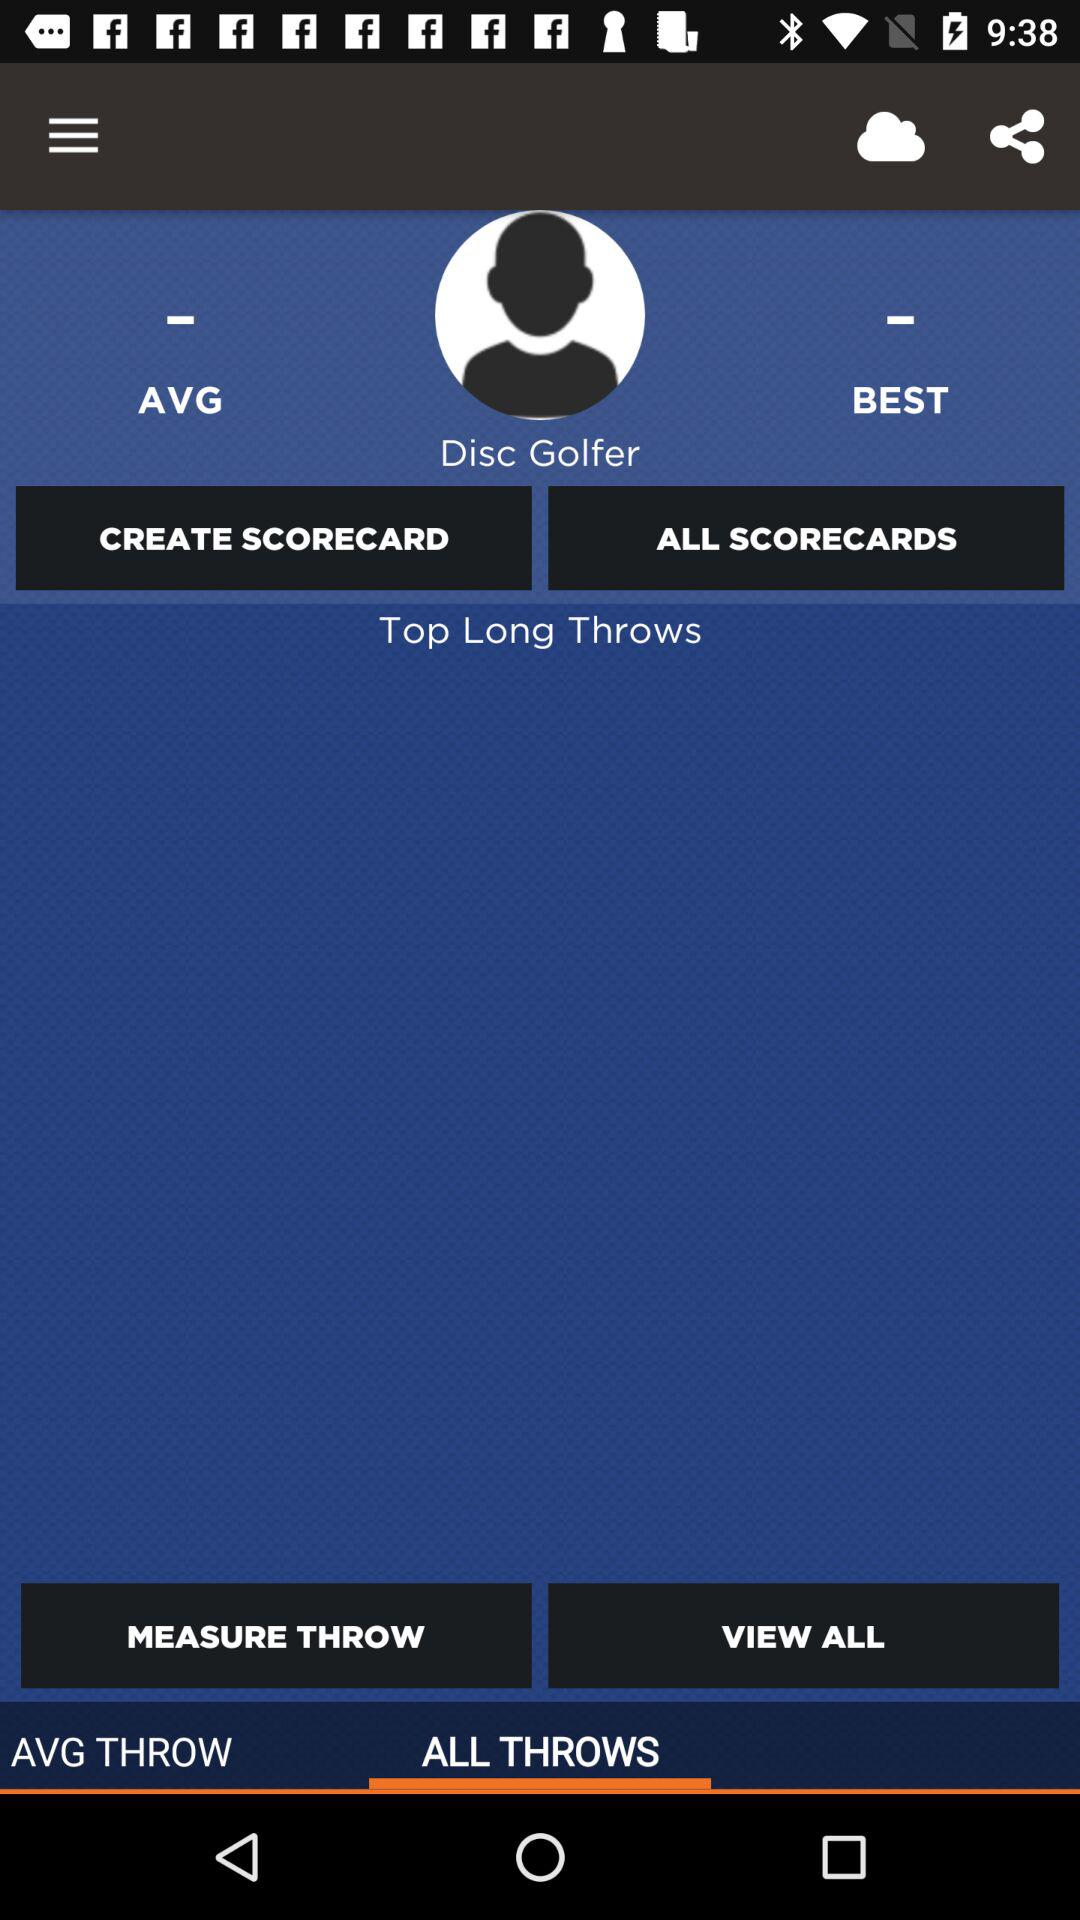Which tab is selected? The selected tab is "ALL THROWS". 